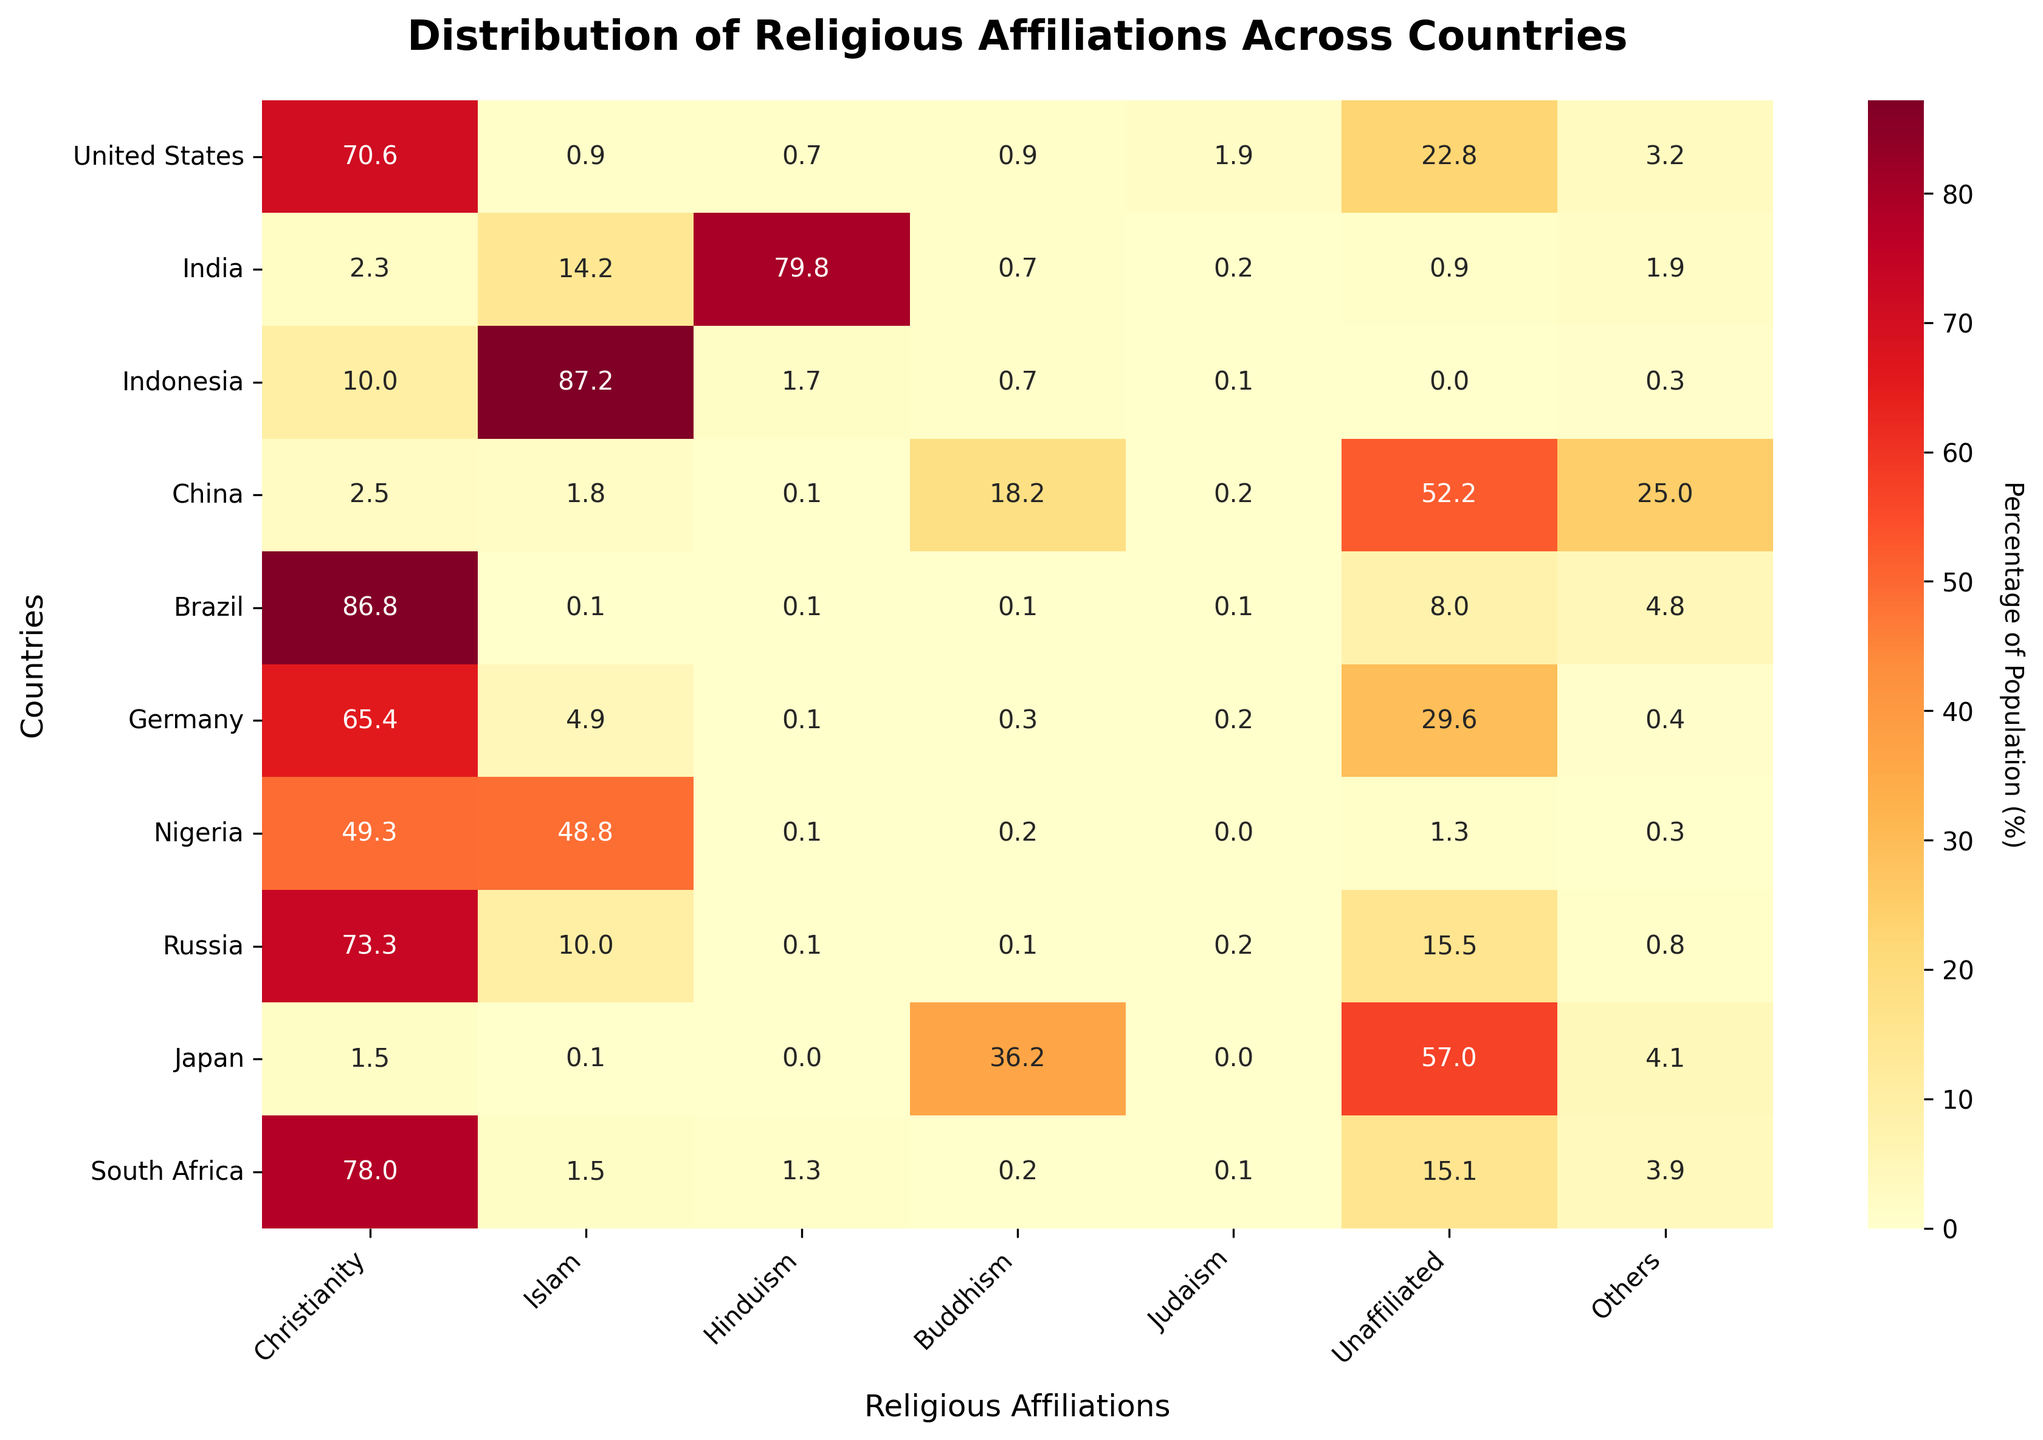What is the majority religion in Brazil? By looking at the heatmap, you can see that Christianity has the highest percentage for Brazil, with a value of 86.8%.
Answer: Christianity Which country has the highest percentage of people identifying as Buddhist? The heatmap shows that Japan has the highest percentage of Buddhists with 36.2%, compared to other countries listed.
Answer: Japan Which country has the largest percentage of unaffiliated people? Referring to the heatmap, China has the largest percentage of unaffiliated people at 52.2%.
Answer: China How does the percentage of Christianity in the United States compare to Germany? According to the heatmap, the percentage of Christians in the United States is 70.6%, while in Germany it is 65.4%. Thus, the United States has a higher percentage.
Answer: United States What is the combined percentage of people who identify as Hindu and Buddhist in India? From the heatmap, Hinduism in India is 79.8% and Buddhism is 0.7%. Summing these values gives 79.8 + 0.7 = 80.5%.
Answer: 80.5% Which country has the most diverse spread of religious affiliations, considering the data provided? China displays significant diversity in religious affiliations with notable percentages across Buddhism, Unaffiliated, and Others, without one single majority dominating the distribution.
Answer: China In which country is Islam the majority religion? The heatmap indicates that in Indonesia, Islam is the majority religion with 87.2%.
Answer: Indonesia Compare the percentage of people identifying as Judaism in the United States and Russia. Which country has a higher percentage? The heatmap shows that Judaism is 1.9% in the United States and 0.16% in Russia. Therefore, the United States has a higher percentage.
Answer: United States What is the percentage difference between the unaffiliated population in Japan and Brazil? From the heatmap, Japan's unaffiliated population is 57%, and Brazil's is 8%. The difference is 57 - 8 = 49%.
Answer: 49% Which countries have a minority religion with a population less than 2%? According to the heatmap, minority religions with populations less than 2% can be found in the United States (Islam, Hinduism, Buddhism, Judaism), India (Everything but Hinduism), Indonesia (Hinduism, Buddhism, Judaism, Unaffiliated, Others), China (All except Unaffiliated), Germany (Hinduism, Buddhism, Judaism, Others), Nigeria (Hinduism, Buddhism, Judaism, Unaffiliated, Others), Russia (Hinduism, Buddhism, Judaism, Others), Japan (Christianity, Islam, Hinduism, Judaism), and South Africa (Islam, Hinduism, Buddhism, Judaism, Others).
Answer: United States, India, Indonesia, China, Germany, Nigeria, Russia, Japan, South Africa 